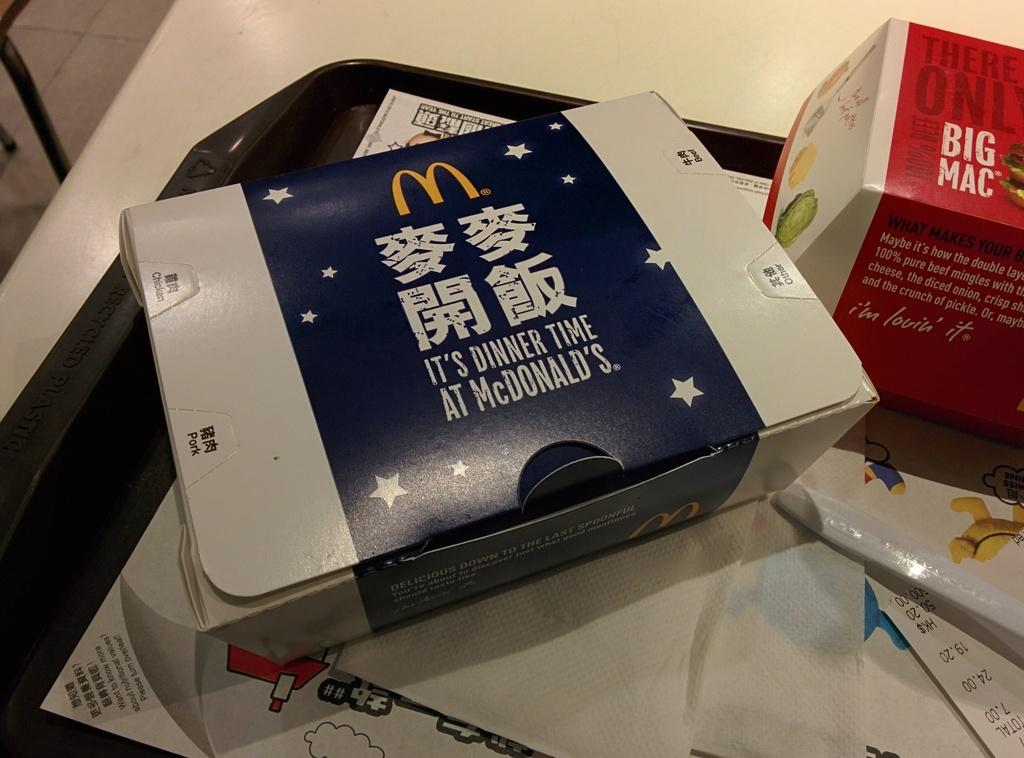<image>
Create a compact narrative representing the image presented. mcdonalds food that is in chinese i see a big mac 